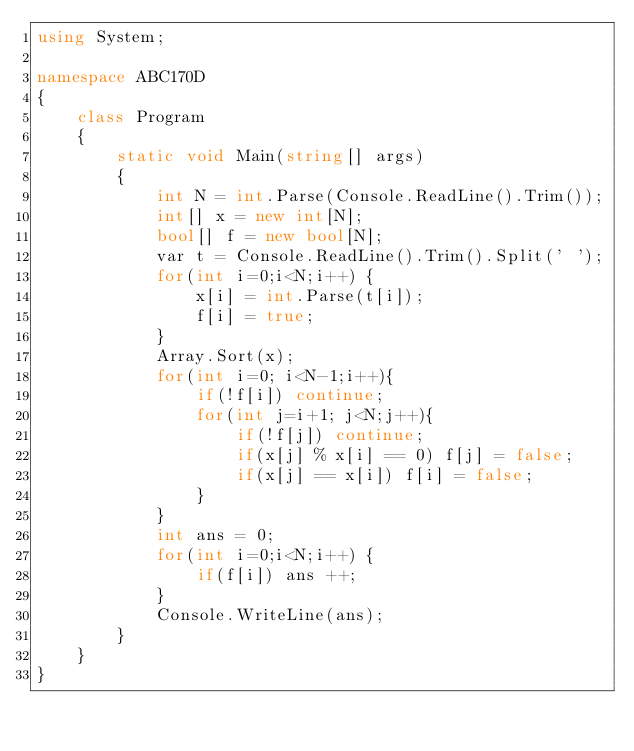<code> <loc_0><loc_0><loc_500><loc_500><_C#_>using System;

namespace ABC170D
{
    class Program
    {
        static void Main(string[] args)
        {
            int N = int.Parse(Console.ReadLine().Trim());
            int[] x = new int[N];
            bool[] f = new bool[N];
            var t = Console.ReadLine().Trim().Split(' ');
            for(int i=0;i<N;i++) { 
                x[i] = int.Parse(t[i]);
                f[i] = true;
            }
            Array.Sort(x);
            for(int i=0; i<N-1;i++){
                if(!f[i]) continue;
                for(int j=i+1; j<N;j++){
                    if(!f[j]) continue;
                    if(x[j] % x[i] == 0) f[j] = false; 
                    if(x[j] == x[i]) f[i] = false;
                }
            }
            int ans = 0;
            for(int i=0;i<N;i++) { 
                if(f[i]) ans ++;
            }
            Console.WriteLine(ans);
        }
    }
}
</code> 